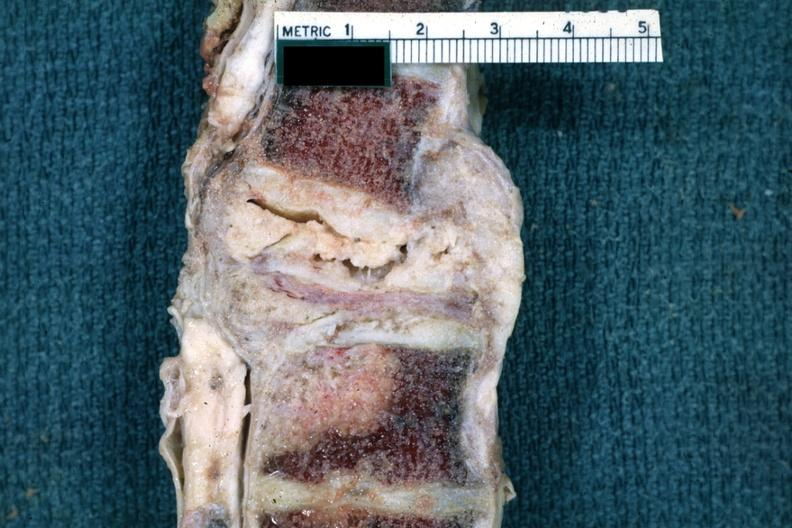s joints present?
Answer the question using a single word or phrase. Yes 